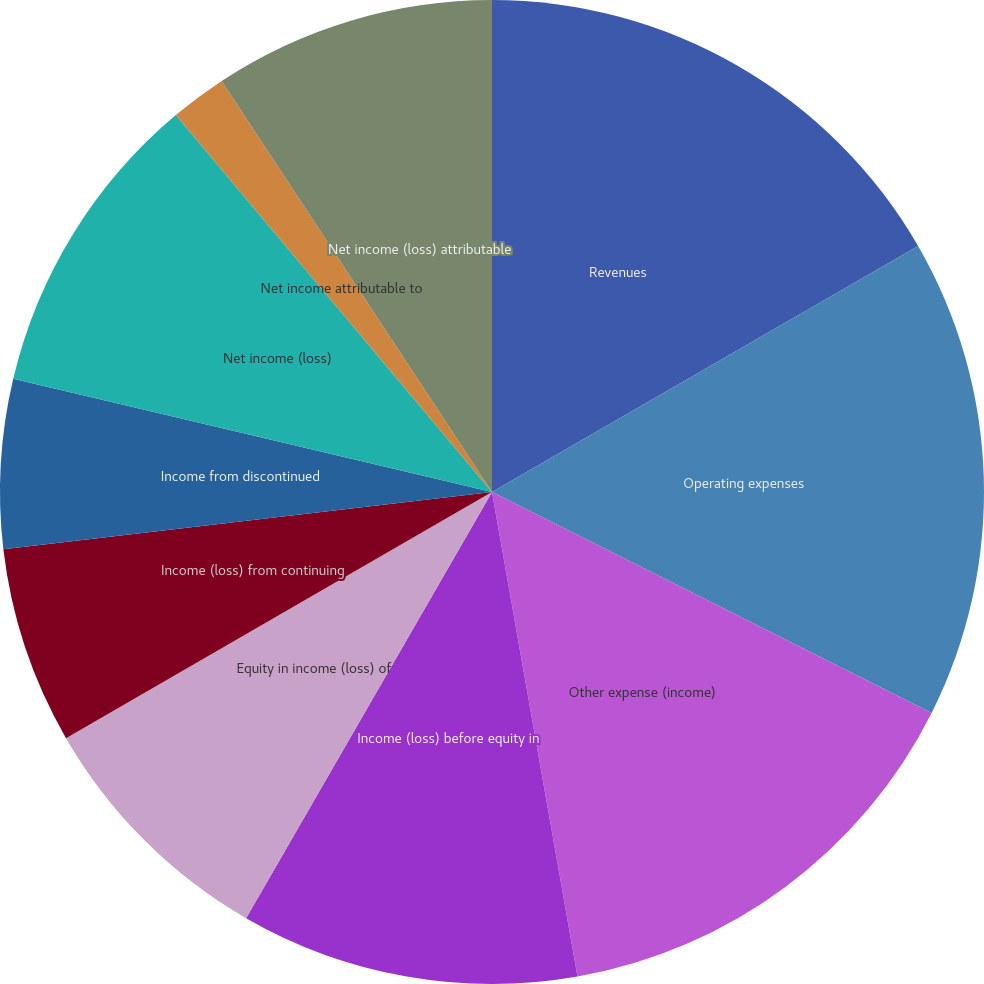Convert chart. <chart><loc_0><loc_0><loc_500><loc_500><pie_chart><fcel>Revenues<fcel>Operating expenses<fcel>Other expense (income)<fcel>Income (loss) before equity in<fcel>Equity in income (loss) of<fcel>Income (loss) from continuing<fcel>Income from discontinued<fcel>Net income (loss)<fcel>Net income attributable to<fcel>Net income (loss) attributable<nl><fcel>16.67%<fcel>15.74%<fcel>14.81%<fcel>11.11%<fcel>8.33%<fcel>6.48%<fcel>5.56%<fcel>10.19%<fcel>1.85%<fcel>9.26%<nl></chart> 